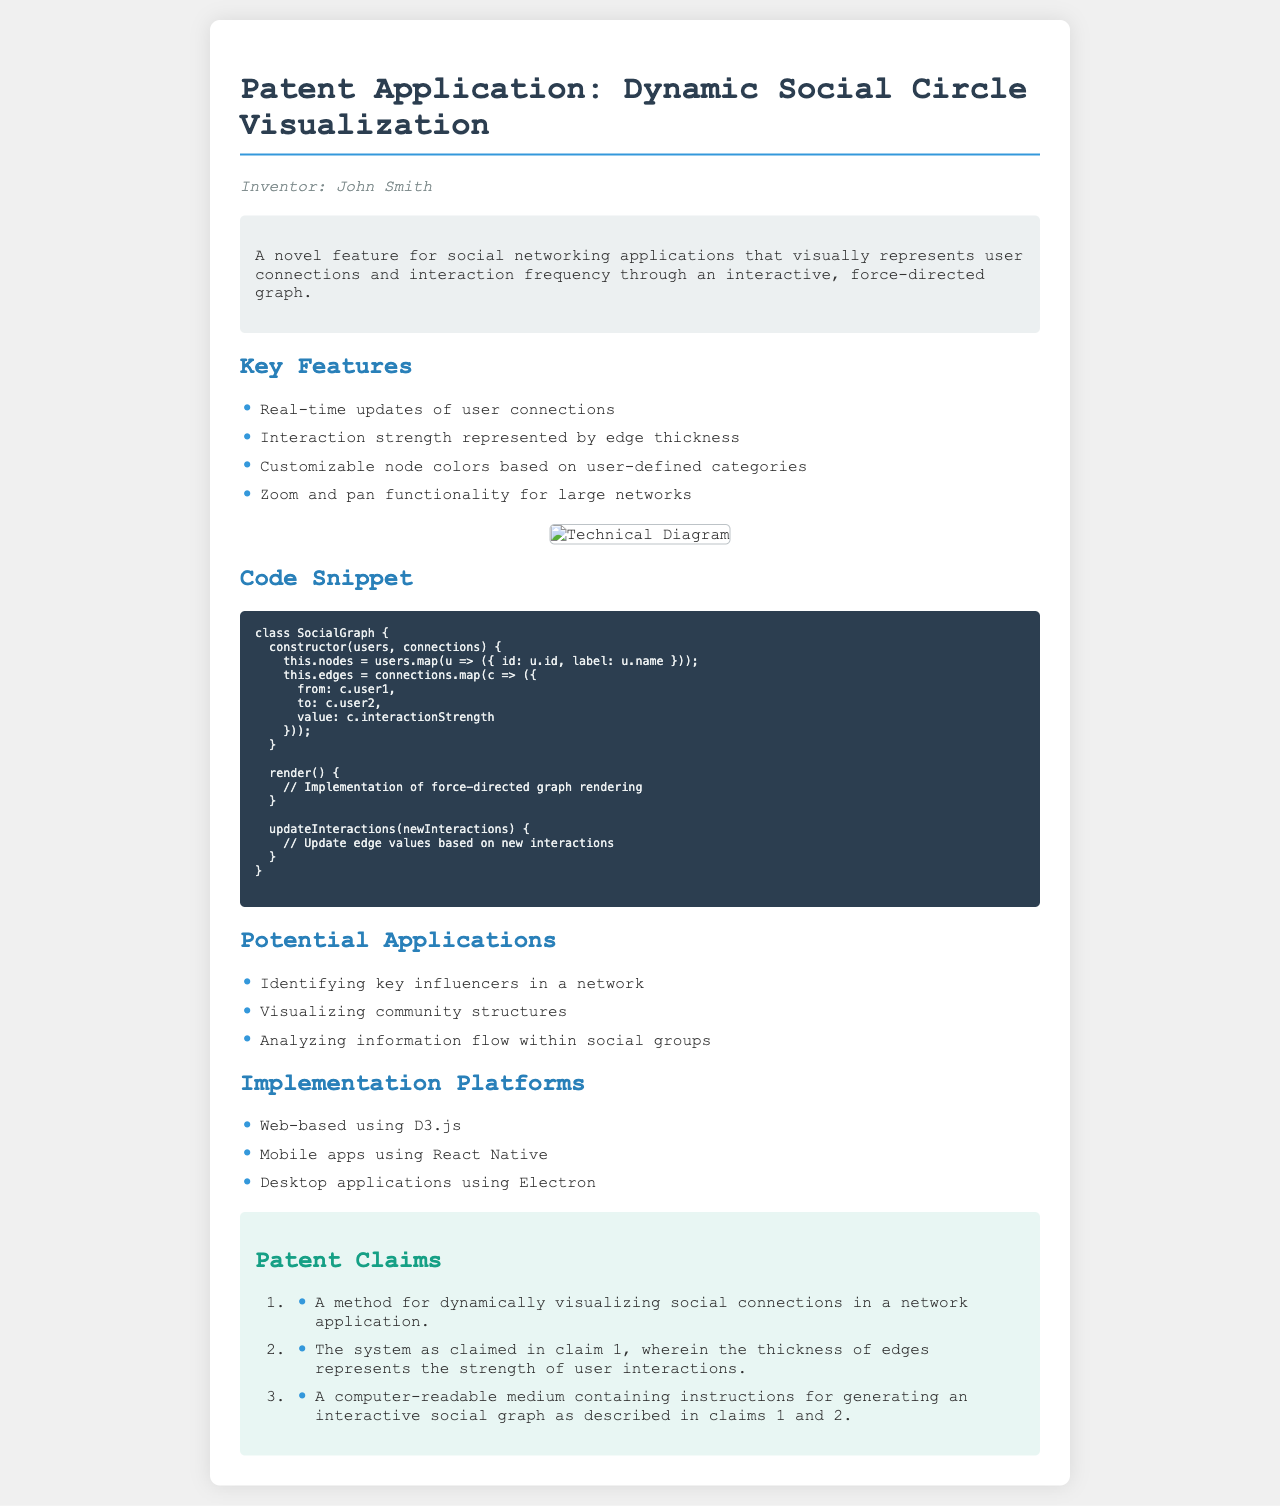What is the title of the patent application? The title is mentioned as the main heading of the document.
Answer: Dynamic Social Circle Visualization Who is the inventor of the patented feature? The inventor's name is provided in the document under the inventor section.
Answer: John Smith What type of graph is described in the patent application? The document specifies that the feature represents connections through a specific type of graph.
Answer: Force-directed graph What programming languages or frameworks are mentioned for implementation? The document lists platforms where the feature can be implemented.
Answer: D3.js, React Native, Electron What is represented by the thickness of edges in the graph? The document explains the meaning of edge thickness in terms of user interactions.
Answer: Interaction strength How many claims are listed in the patent claims section? The claims section contains an ordered list of claims made in the application.
Answer: Three What does the class ‘SocialGraph’ constructor take as parameters? The constructor's parameters are specified in the code snippet provided in the document.
Answer: Users, connections What is a potential application of the dynamic visualization feature? The document lists various potential applications of the described feature.
Answer: Identifying key influencers in a network What does the description of the feature include? The description provides a summary of what the feature does and its function.
Answer: Visually represents user connections and interaction frequency 